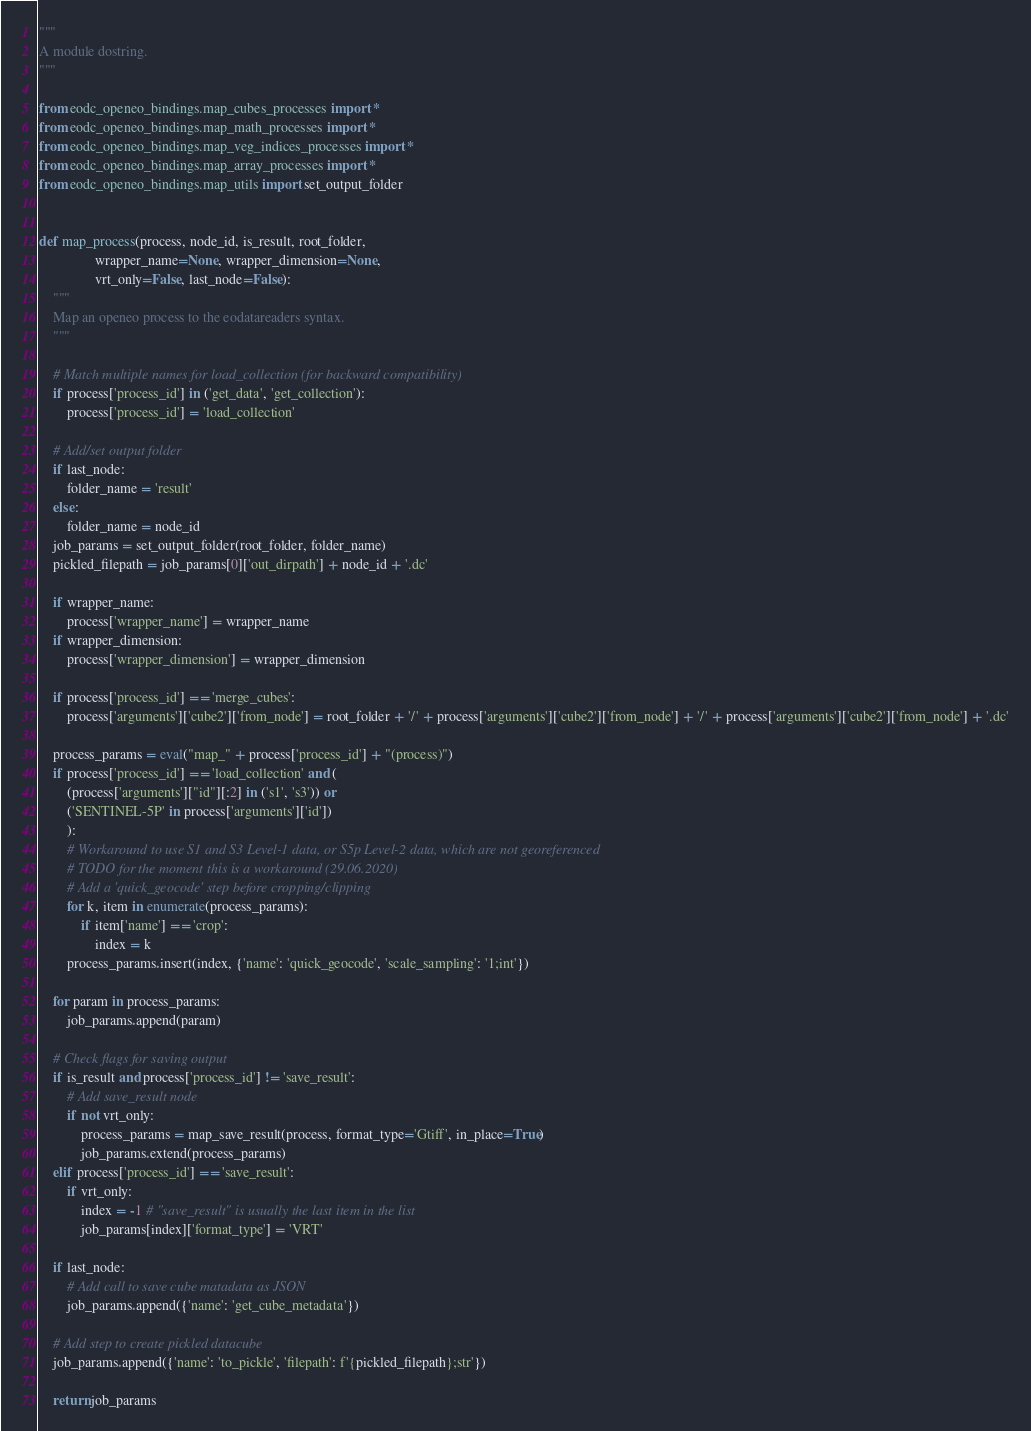<code> <loc_0><loc_0><loc_500><loc_500><_Python_>"""
A module dostring.
"""

from eodc_openeo_bindings.map_cubes_processes import *
from eodc_openeo_bindings.map_math_processes import *
from eodc_openeo_bindings.map_veg_indices_processes import *
from eodc_openeo_bindings.map_array_processes import *
from eodc_openeo_bindings.map_utils import set_output_folder


def map_process(process, node_id, is_result, root_folder,
                wrapper_name=None, wrapper_dimension=None,
                vrt_only=False, last_node=False):
    """
    Map an openeo process to the eodatareaders syntax.
    """
    
    # Match multiple names for load_collection (for backward compatibility)
    if process['process_id'] in ('get_data', 'get_collection'):
        process['process_id'] = 'load_collection'

    # Add/set output folder
    if last_node:
        folder_name = 'result'
    else:
        folder_name = node_id
    job_params = set_output_folder(root_folder, folder_name)
    pickled_filepath = job_params[0]['out_dirpath'] + node_id + '.dc'
    
    if wrapper_name:
        process['wrapper_name'] = wrapper_name
    if wrapper_dimension:
        process['wrapper_dimension'] = wrapper_dimension
    
    if process['process_id'] == 'merge_cubes':
        process['arguments']['cube2']['from_node'] = root_folder + '/' + process['arguments']['cube2']['from_node'] + '/' + process['arguments']['cube2']['from_node'] + '.dc'
        
    process_params = eval("map_" + process['process_id'] + "(process)")
    if process['process_id'] == 'load_collection' and (
        (process['arguments']["id"][:2] in ('s1', 's3')) or
        ('SENTINEL-5P' in process['arguments']['id'])
        ):
        # Workaround to use S1 and S3 Level-1 data, or S5p Level-2 data, which are not georeferenced
        # TODO for the moment this is a workaround (29.06.2020)
        # Add a 'quick_geocode' step before cropping/clipping
        for k, item in enumerate(process_params):
            if item['name'] == 'crop':
                index = k
        process_params.insert(index, {'name': 'quick_geocode', 'scale_sampling': '1;int'})

    for param in process_params:
        job_params.append(param)
    
    # Check flags for saving output
    if is_result and process['process_id'] != 'save_result':
        # Add save_result node
        if not vrt_only:
            process_params = map_save_result(process, format_type='Gtiff', in_place=True) 
            job_params.extend(process_params)
    elif process['process_id'] == 'save_result':
        if vrt_only:
            index = -1 # "save_result" is usually the last item in the list
            job_params[index]['format_type'] = 'VRT'
    
    if last_node:
        # Add call to save cube matadata as JSON
        job_params.append({'name': 'get_cube_metadata'})
        
    # Add step to create pickled datacube
    job_params.append({'name': 'to_pickle', 'filepath': f'{pickled_filepath};str'})

    return job_params
</code> 